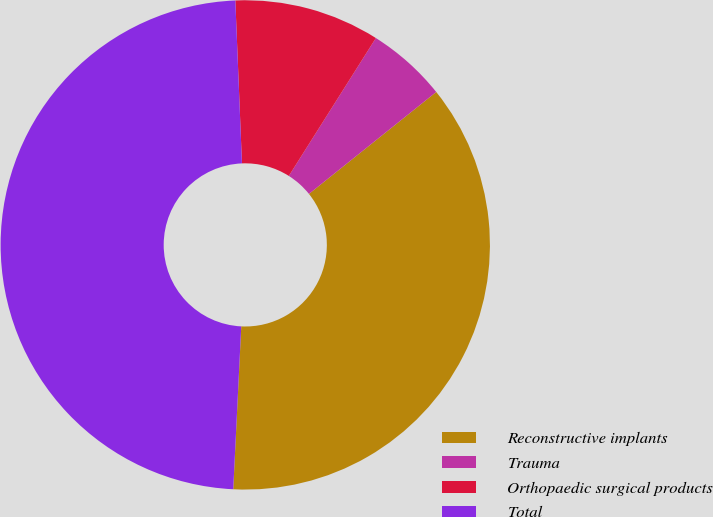Convert chart. <chart><loc_0><loc_0><loc_500><loc_500><pie_chart><fcel>Reconstructive implants<fcel>Trauma<fcel>Orthopaedic surgical products<fcel>Total<nl><fcel>36.53%<fcel>5.29%<fcel>9.61%<fcel>48.57%<nl></chart> 